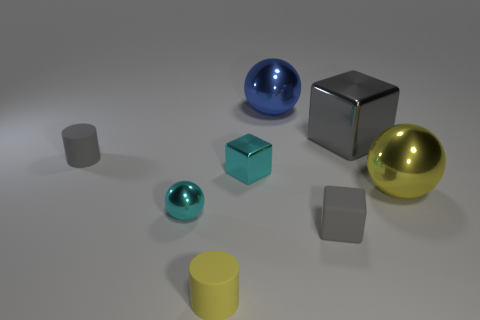Add 2 tiny rubber cubes. How many objects exist? 10 Subtract all spheres. How many objects are left? 5 Subtract all tiny gray objects. Subtract all big shiny balls. How many objects are left? 4 Add 7 yellow matte objects. How many yellow matte objects are left? 8 Add 3 small yellow rubber cubes. How many small yellow rubber cubes exist? 3 Subtract 0 green balls. How many objects are left? 8 